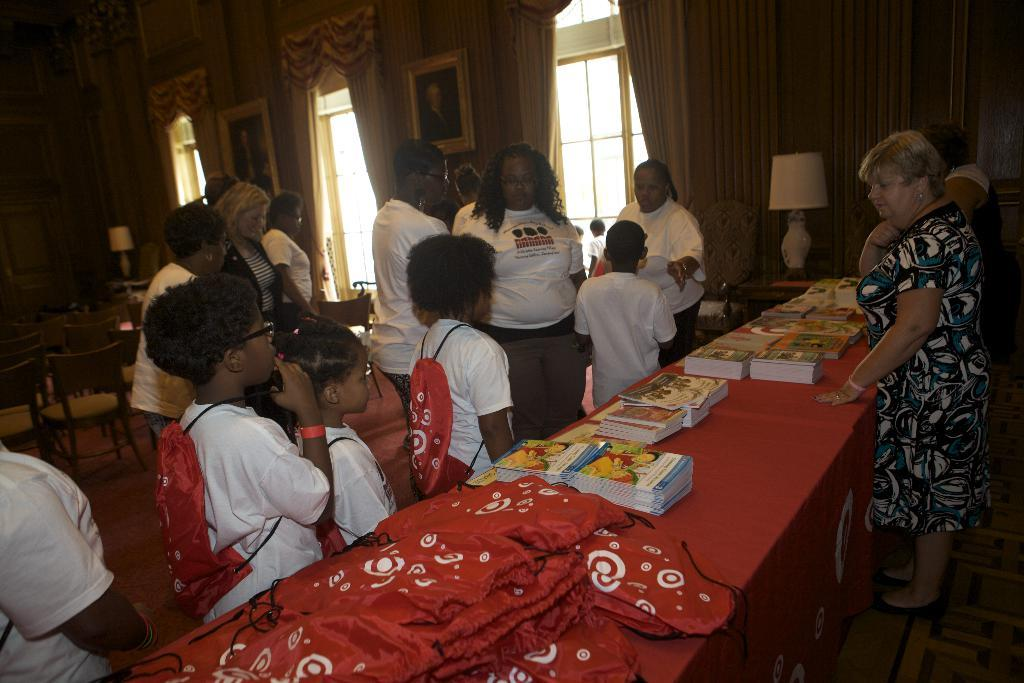What can be seen in the background of the image? There are persons standing in the background of the image. What is present in the image that might frame a view or object? There is a frame in the image. What type of window treatment is visible in the image? There is a curtain in the image. What architectural feature is present in the image? There is a door in the image. What items are on the table in the image? There are books on a table in the image. What type of lighting is present in the image? There is a lamp in the image. What type of lip can be seen on the door in the image? There is no lip present on the door in the image. How does the person in the background of the image help with the books on the table? The image does not show any interaction between the person in the background and the books on the table, so it cannot be determined if they are helping. 